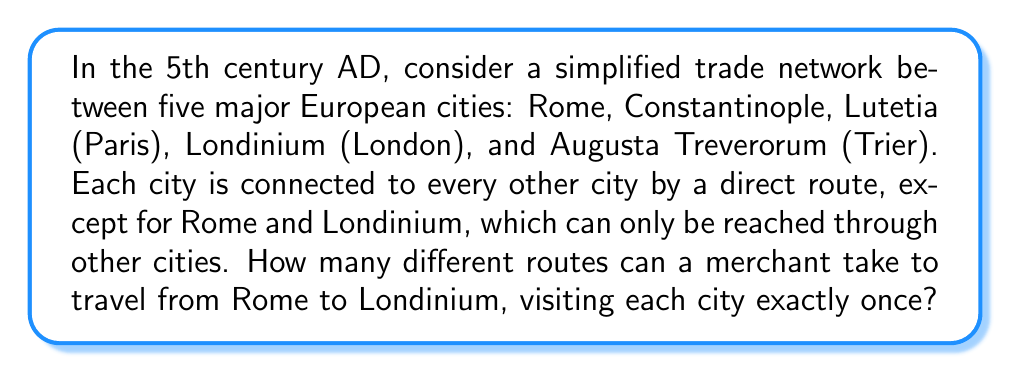Could you help me with this problem? Let's approach this step-by-step:

1) First, we need to visualize the network. We can represent it as follows:

   [asy]
   import geometry;
   
   pair Rome=(0,0), Constantinople=(2,0), Lutetia=(1,2), Londinium=(0,3), Trier=(2,3);
   
   dot("Rome", Rome, S);
   dot("Constantinople", Constantinople, S);
   dot("Lutetia", Lutetia, N);
   dot("Londinium", Londinium, N);
   dot("Trier", Trier, N);
   
   draw(Rome--Constantinople--Lutetia--Londinium--Trier--Rome);
   draw(Constantinople--Trier);
   draw(Rome--Lutetia);
   draw(Rome--Trier);
   draw(Constantinople--Londinium);
   [/asy]

2) The merchant must start at Rome and end at Londinium, visiting each city once. This means we need to arrange the other three cities (Constantinople, Lutetia, and Trier) in all possible orders.

3) This is a permutation problem. The number of ways to arrange 3 items is $3! = 3 \times 2 \times 1 = 6$.

4) Let's list all these possibilities:
   - Rome → Constantinople → Lutetia → Trier → Londinium
   - Rome → Constantinople → Trier → Lutetia → Londinium
   - Rome → Lutetia → Constantinople → Trier → Londinium
   - Rome → Lutetia → Trier → Constantinople → Londinium
   - Rome → Trier → Constantinople → Lutetia → Londinium
   - Rome → Trier → Lutetia → Constantinople → Londinium

5) Each of these routes is valid according to our network, as Rome and Londinium are always connected through other cities.

6) Therefore, the total number of possible routes is 6.
Answer: 6 